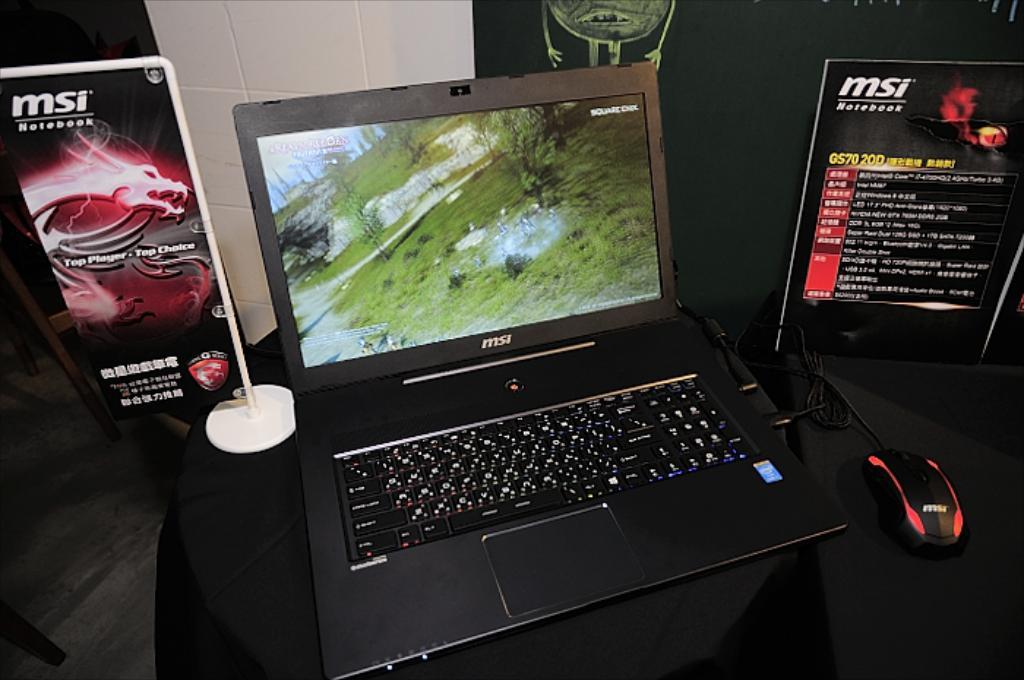<image>
Give a short and clear explanation of the subsequent image. An open MSI laptop sitting on a black table between two MSI advertising signs. 